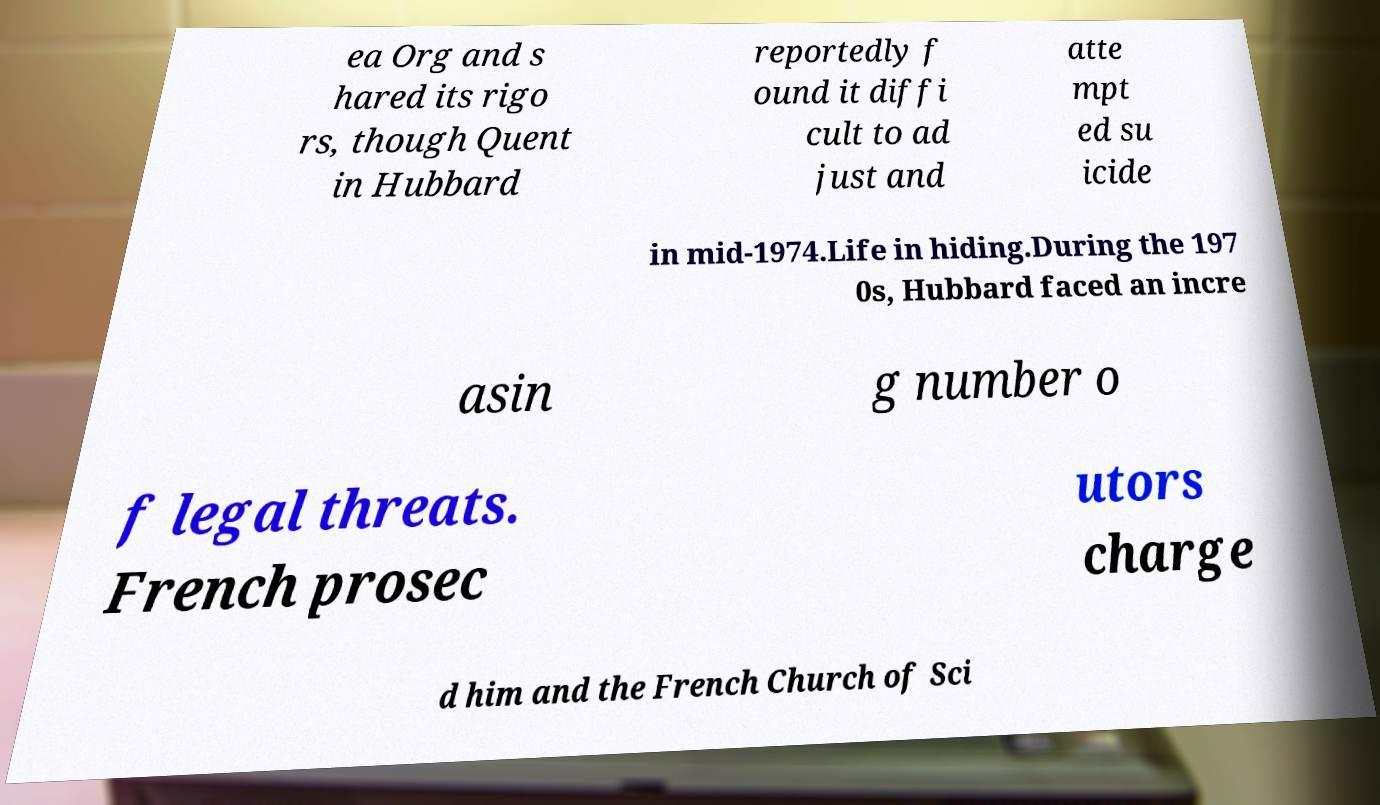Please read and relay the text visible in this image. What does it say? ea Org and s hared its rigo rs, though Quent in Hubbard reportedly f ound it diffi cult to ad just and atte mpt ed su icide in mid-1974.Life in hiding.During the 197 0s, Hubbard faced an incre asin g number o f legal threats. French prosec utors charge d him and the French Church of Sci 